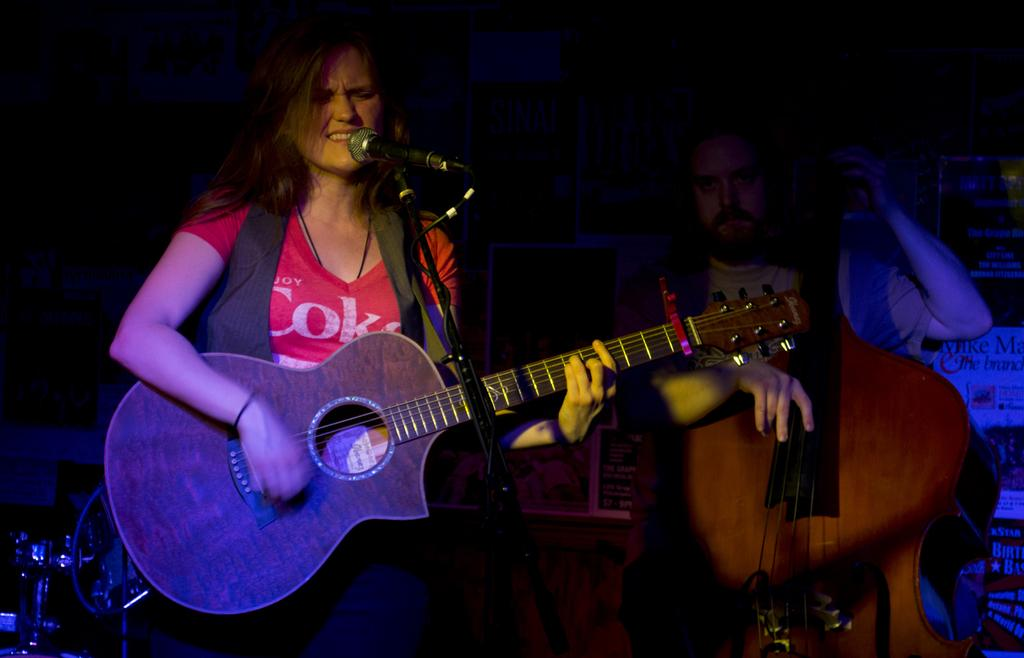What is the woman in the image doing? The woman in the image is singing and playing a guitar. What is in front of the woman? There is a stand in front of the woman. Can you describe the man in the background of the image? The man in the background of the image is holding a large guitar. What type of pancake is the woman flipping in the image? There is no pancake present in the image; the woman is singing and playing a guitar. What kind of animal can be seen interacting with the woman in the image? There are no animals present in the image; the woman is accompanied by a man holding a large guitar in the background. 